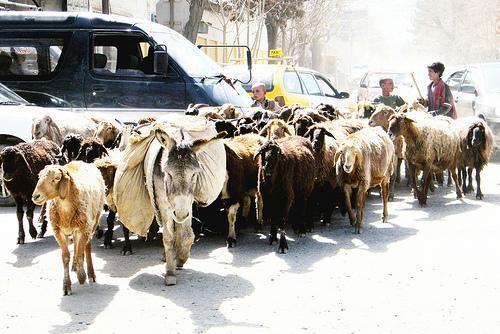How many donkeys are there?
Give a very brief answer. 1. How many cars are there?
Give a very brief answer. 4. How many people are there?
Give a very brief answer. 3. 